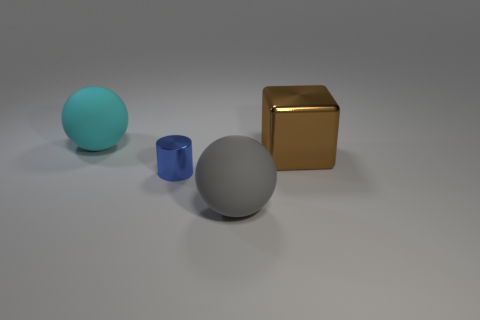What materials do the objects in this image appear to be made of? Based on the visual qualities in the image, the objects appear to be made of different materials. The large sphere has a matte cyan finish, suggesting a plastic or painted surface. The cube has a reflective golden surface, evoking the look of polished metal. The remaining two, the smaller blue cylinder and the grey sphere, have qualities that suggest glass and smooth stone or metal, respectively. 